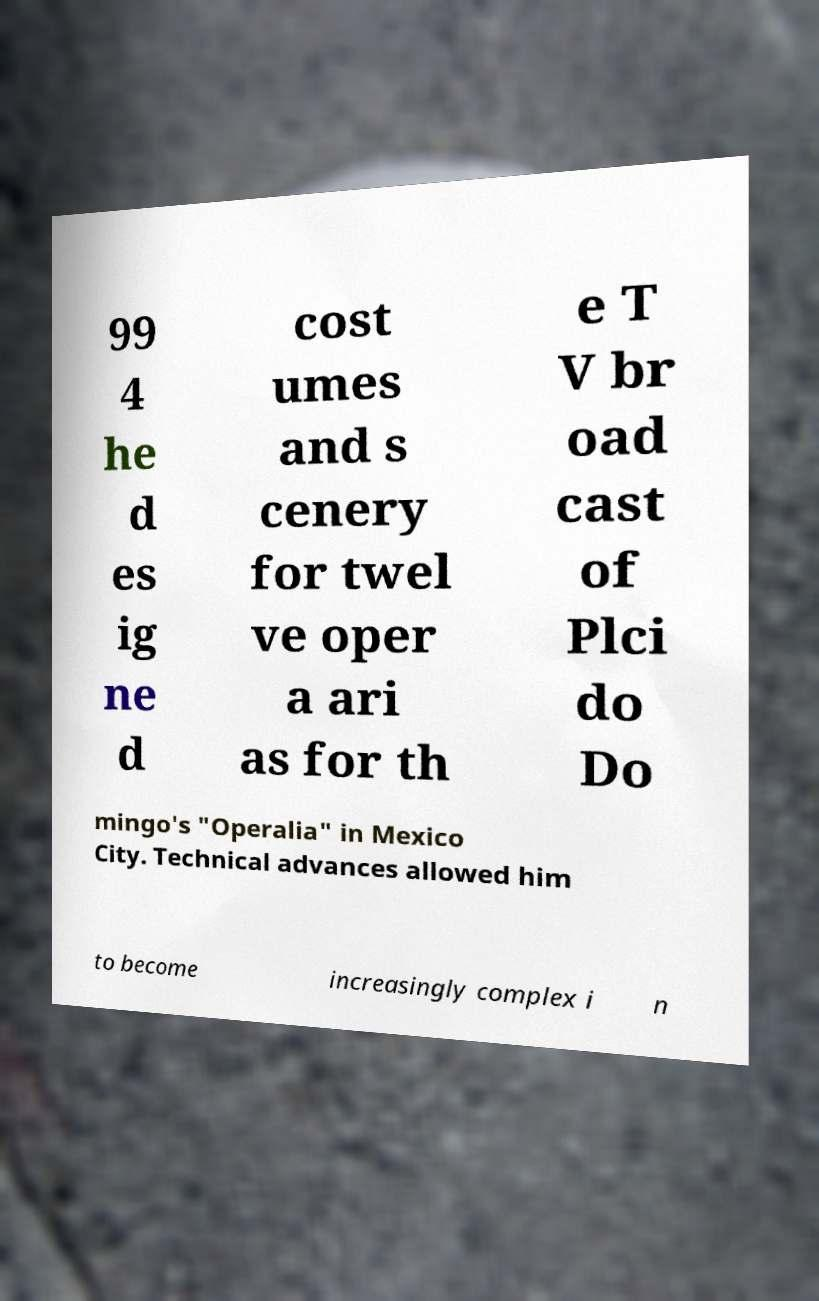Can you accurately transcribe the text from the provided image for me? 99 4 he d es ig ne d cost umes and s cenery for twel ve oper a ari as for th e T V br oad cast of Plci do Do mingo's "Operalia" in Mexico City. Technical advances allowed him to become increasingly complex i n 